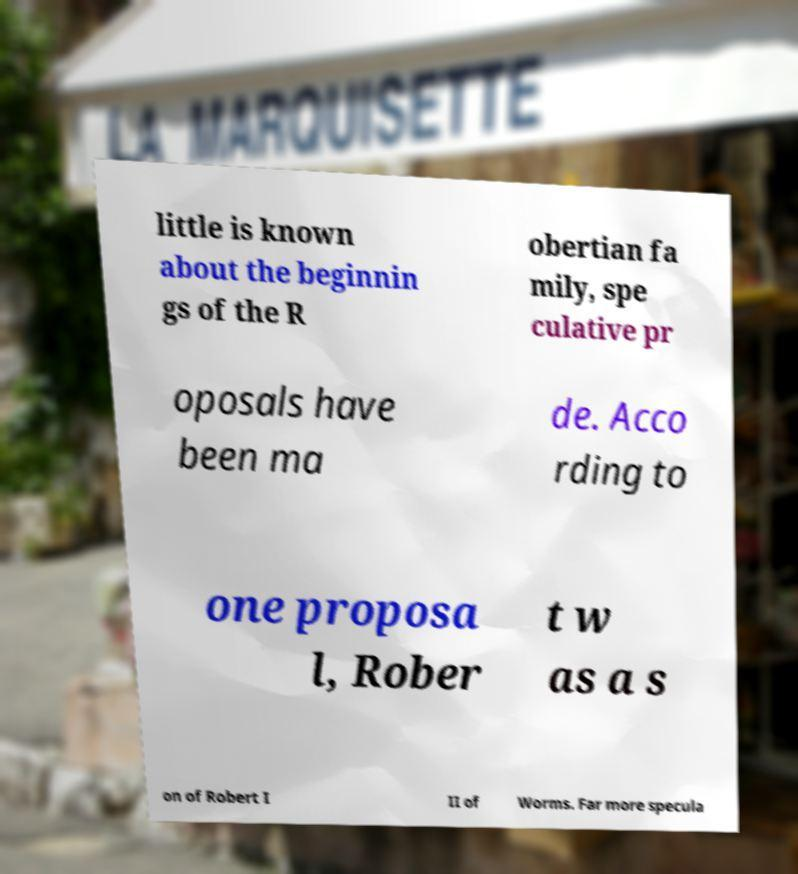Can you read and provide the text displayed in the image?This photo seems to have some interesting text. Can you extract and type it out for me? little is known about the beginnin gs of the R obertian fa mily, spe culative pr oposals have been ma de. Acco rding to one proposa l, Rober t w as a s on of Robert I II of Worms. Far more specula 